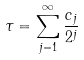<formula> <loc_0><loc_0><loc_500><loc_500>\tau = \sum _ { j = 1 } ^ { \infty } \frac { c _ { j } } { 2 ^ { j } }</formula> 